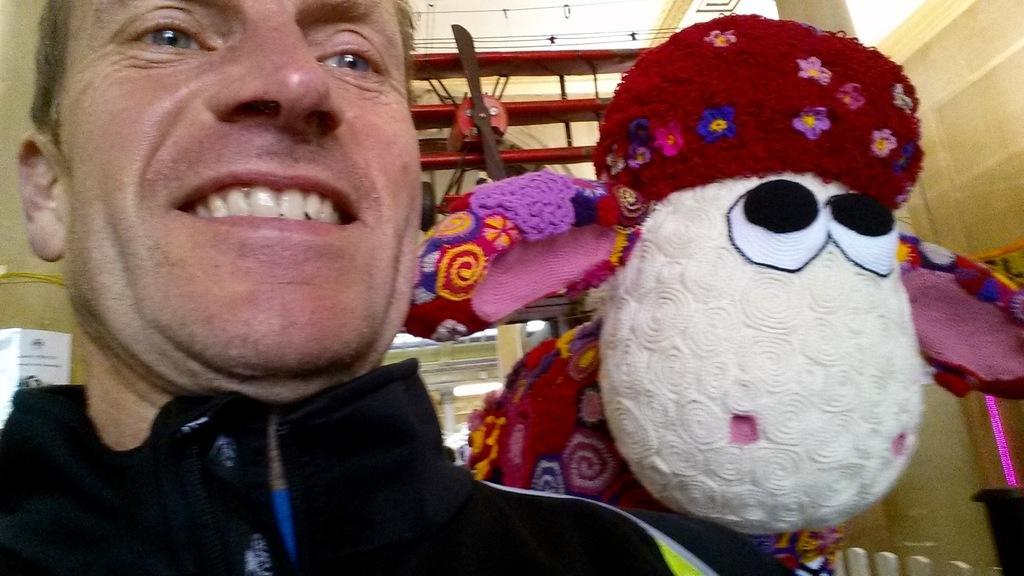What is the person in the image wearing? The person in the image is wearing a black dress. What can be seen in the background of the image? In the background of the image, there is a doll, an airplane, and a light. Can you describe the doll in the background? The facts provided do not give any details about the doll, so we cannot describe it further. What type of toy is the secretary playing with during the meeting in the image? There is no secretary or toy present in the image. 